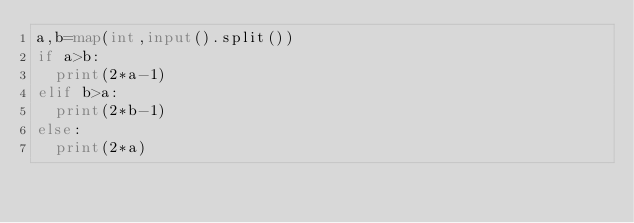<code> <loc_0><loc_0><loc_500><loc_500><_Python_>a,b=map(int,input().split())
if a>b:
  print(2*a-1)
elif b>a:
  print(2*b-1)
else:
  print(2*a)</code> 